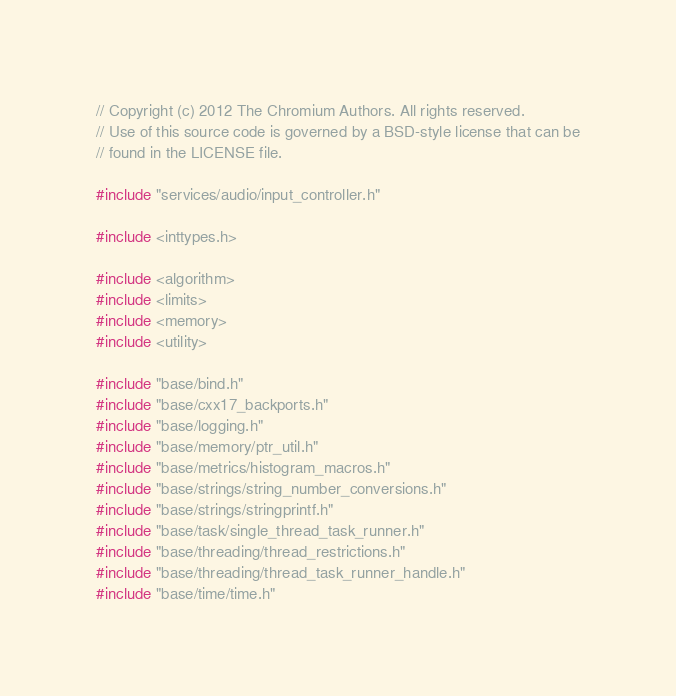<code> <loc_0><loc_0><loc_500><loc_500><_C++_>// Copyright (c) 2012 The Chromium Authors. All rights reserved.
// Use of this source code is governed by a BSD-style license that can be
// found in the LICENSE file.

#include "services/audio/input_controller.h"

#include <inttypes.h>

#include <algorithm>
#include <limits>
#include <memory>
#include <utility>

#include "base/bind.h"
#include "base/cxx17_backports.h"
#include "base/logging.h"
#include "base/memory/ptr_util.h"
#include "base/metrics/histogram_macros.h"
#include "base/strings/string_number_conversions.h"
#include "base/strings/stringprintf.h"
#include "base/task/single_thread_task_runner.h"
#include "base/threading/thread_restrictions.h"
#include "base/threading/thread_task_runner_handle.h"
#include "base/time/time.h"</code> 